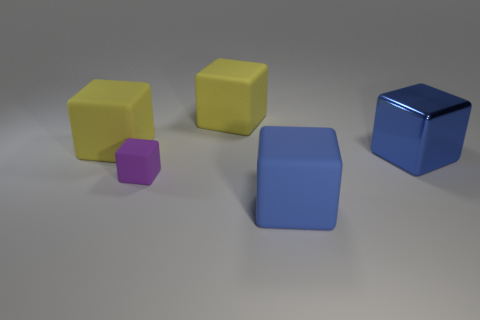Is the number of things that are behind the small object greater than the number of tiny matte things?
Your answer should be very brief. Yes. There is a purple matte thing that is the same shape as the big blue matte object; what size is it?
Give a very brief answer. Small. What shape is the big blue metallic object?
Your answer should be very brief. Cube. There is a blue matte thing that is the same size as the blue metallic block; what is its shape?
Make the answer very short. Cube. Is there any other thing that has the same color as the small block?
Give a very brief answer. No. Is the shape of the shiny thing the same as the blue thing that is to the left of the large metallic cube?
Offer a very short reply. Yes. The purple object is what size?
Give a very brief answer. Small. Are there fewer rubber things in front of the blue metallic thing than rubber objects?
Your answer should be very brief. Yes. How many rubber blocks have the same size as the blue metal object?
Provide a succinct answer. 3. What shape is the thing that is the same color as the metallic block?
Give a very brief answer. Cube. 